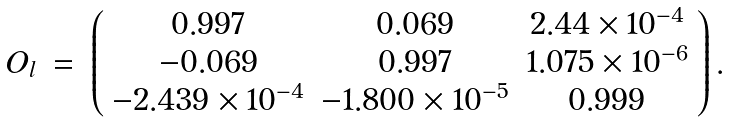Convert formula to latex. <formula><loc_0><loc_0><loc_500><loc_500>\begin{array} { l l l } O _ { l } & = & \left ( \begin{array} { c c c } 0 . 9 9 7 & 0 . 0 6 9 & 2 . 4 4 \times 1 0 ^ { - 4 } \\ - 0 . 0 6 9 & 0 . 9 9 7 & 1 . 0 7 5 \times 1 0 ^ { - 6 } \\ - 2 . 4 3 9 \times 1 0 ^ { - 4 } & - 1 . 8 0 0 \times 1 0 ^ { - 5 } & 0 . 9 9 9 \end{array} \right ) . \end{array}</formula> 